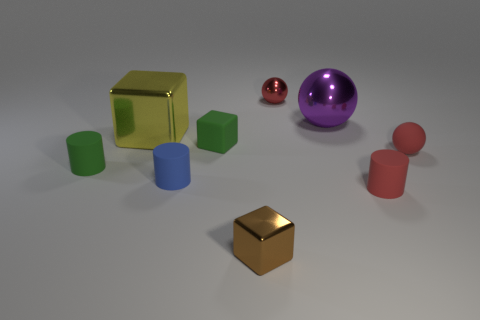Subtract all small cubes. How many cubes are left? 1 Subtract all gray cylinders. How many red balls are left? 2 Subtract 1 cylinders. How many cylinders are left? 2 Add 1 small blue rubber objects. How many objects exist? 10 Subtract all cyan cylinders. Subtract all yellow cubes. How many cylinders are left? 3 Subtract all balls. How many objects are left? 6 Subtract all tiny red balls. Subtract all big metal cubes. How many objects are left? 6 Add 4 yellow objects. How many yellow objects are left? 5 Add 6 purple things. How many purple things exist? 7 Subtract 0 purple blocks. How many objects are left? 9 